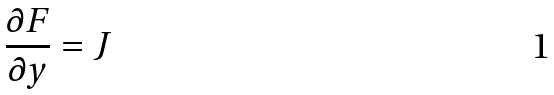Convert formula to latex. <formula><loc_0><loc_0><loc_500><loc_500>\frac { \partial F } { \partial y } = J</formula> 